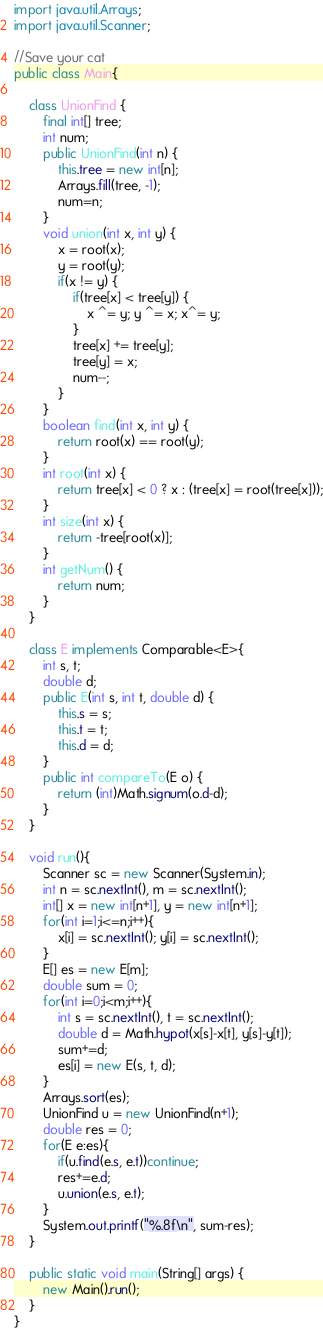Convert code to text. <code><loc_0><loc_0><loc_500><loc_500><_Java_>import java.util.Arrays;
import java.util.Scanner;

//Save your cat
public class Main{
	
	class UnionFind {
		final int[] tree;
		int num;
		public UnionFind(int n) {
			this.tree = new int[n];
			Arrays.fill(tree, -1);
			num=n;
		}
		void union(int x, int y) {
			x = root(x);
			y = root(y);
			if(x != y) {
				if(tree[x] < tree[y]) {
					x ^= y; y ^= x; x^= y;
				}
				tree[x] += tree[y];
				tree[y] = x;
				num--;
			}
		}
		boolean find(int x, int y) {
			return root(x) == root(y);
		}
		int root(int x) {
			return tree[x] < 0 ? x : (tree[x] = root(tree[x]));
		}
		int size(int x) {
			return -tree[root(x)];
		}
		int getNum() {
			return num;
		}
	}
	
	class E implements Comparable<E>{
		int s, t;
		double d;
		public E(int s, int t, double d) {
			this.s = s;
			this.t = t;
			this.d = d;
		}
		public int compareTo(E o) {
			return (int)Math.signum(o.d-d);
		}
	}
	
	void run(){
		Scanner sc = new Scanner(System.in);
		int n = sc.nextInt(), m = sc.nextInt();
		int[] x = new int[n+1], y = new int[n+1];
		for(int i=1;i<=n;i++){
			x[i] = sc.nextInt(); y[i] = sc.nextInt();
		}
		E[] es = new E[m];
		double sum = 0;
		for(int i=0;i<m;i++){
			int s = sc.nextInt(), t = sc.nextInt();
			double d = Math.hypot(x[s]-x[t], y[s]-y[t]);
			sum+=d;
			es[i] = new E(s, t, d);
		}
		Arrays.sort(es);
		UnionFind u = new UnionFind(n+1);
		double res = 0;
		for(E e:es){
			if(u.find(e.s, e.t))continue;
			res+=e.d;
			u.union(e.s, e.t);
		}
		System.out.printf("%.8f\n", sum-res);
	}
	
	public static void main(String[] args) {
		new Main().run();
	}
}</code> 